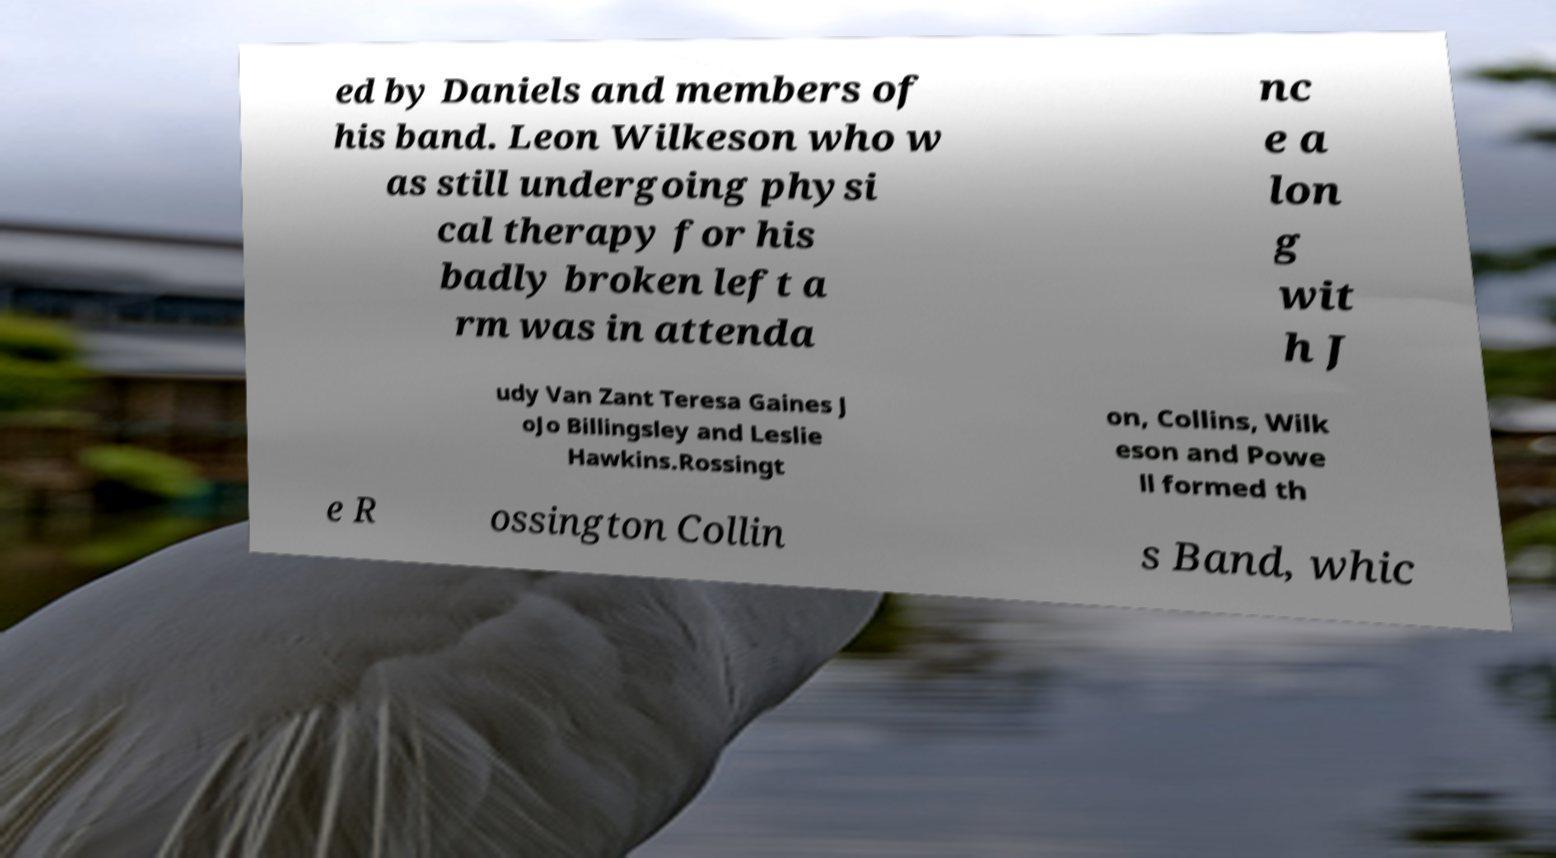Please read and relay the text visible in this image. What does it say? ed by Daniels and members of his band. Leon Wilkeson who w as still undergoing physi cal therapy for his badly broken left a rm was in attenda nc e a lon g wit h J udy Van Zant Teresa Gaines J oJo Billingsley and Leslie Hawkins.Rossingt on, Collins, Wilk eson and Powe ll formed th e R ossington Collin s Band, whic 